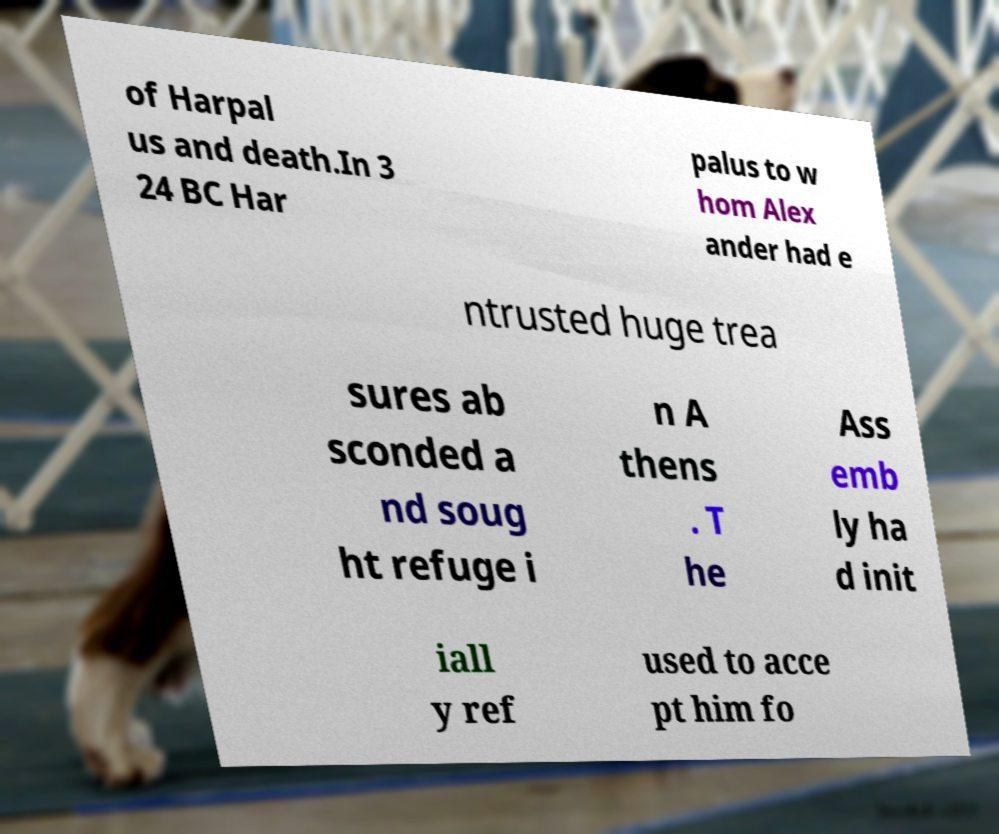Please identify and transcribe the text found in this image. of Harpal us and death.In 3 24 BC Har palus to w hom Alex ander had e ntrusted huge trea sures ab sconded a nd soug ht refuge i n A thens . T he Ass emb ly ha d init iall y ref used to acce pt him fo 